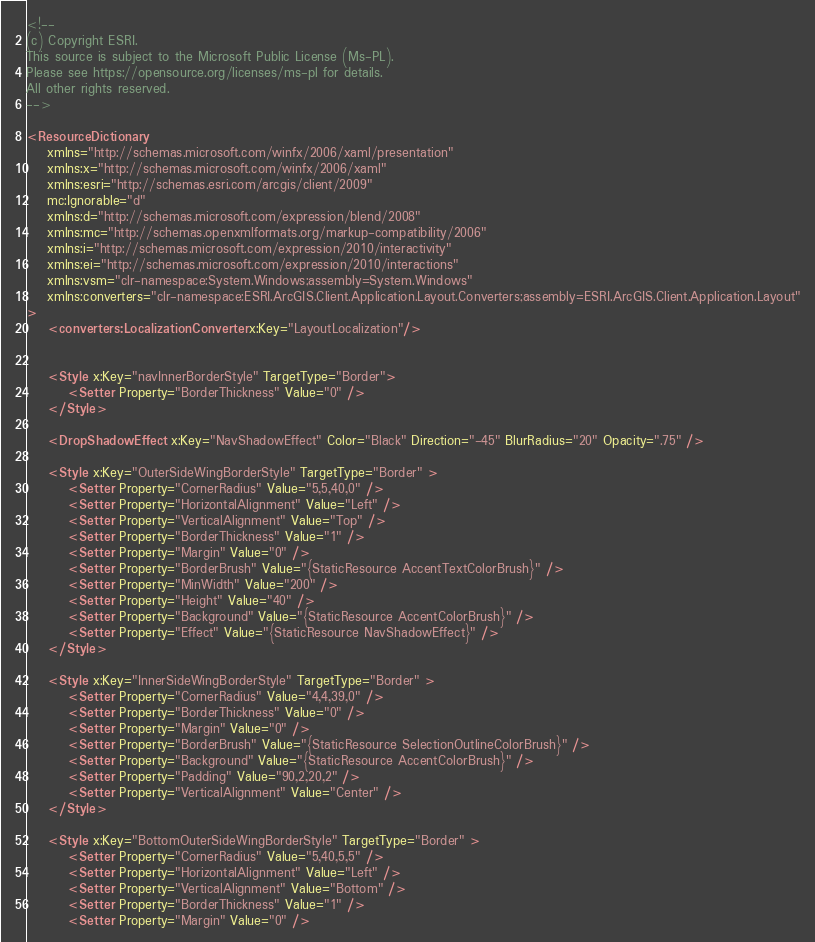<code> <loc_0><loc_0><loc_500><loc_500><_XML_><!--
(c) Copyright ESRI.
This source is subject to the Microsoft Public License (Ms-PL).
Please see https://opensource.org/licenses/ms-pl for details.
All other rights reserved.
-->

<ResourceDictionary
    xmlns="http://schemas.microsoft.com/winfx/2006/xaml/presentation" 
    xmlns:x="http://schemas.microsoft.com/winfx/2006/xaml"    
    xmlns:esri="http://schemas.esri.com/arcgis/client/2009"        
    mc:Ignorable="d" 
    xmlns:d="http://schemas.microsoft.com/expression/blend/2008"
    xmlns:mc="http://schemas.openxmlformats.org/markup-compatibility/2006"
    xmlns:i="http://schemas.microsoft.com/expression/2010/interactivity"
    xmlns:ei="http://schemas.microsoft.com/expression/2010/interactions" 
    xmlns:vsm="clr-namespace:System.Windows;assembly=System.Windows"
	xmlns:converters="clr-namespace:ESRI.ArcGIS.Client.Application.Layout.Converters;assembly=ESRI.ArcGIS.Client.Application.Layout"
>
    <converters:LocalizationConverter x:Key="LayoutLocalization"/>

    
    <Style x:Key="navInnerBorderStyle" TargetType="Border">
        <Setter Property="BorderThickness" Value="0" />
    </Style>

    <DropShadowEffect x:Key="NavShadowEffect" Color="Black" Direction="-45" BlurRadius="20" Opacity=".75" />

    <Style x:Key="OuterSideWingBorderStyle" TargetType="Border" >
        <Setter Property="CornerRadius" Value="5,5,40,0" />
        <Setter Property="HorizontalAlignment" Value="Left" />
        <Setter Property="VerticalAlignment" Value="Top" />
        <Setter Property="BorderThickness" Value="1" />
        <Setter Property="Margin" Value="0" /> 
        <Setter Property="BorderBrush" Value="{StaticResource AccentTextColorBrush}" />
        <Setter Property="MinWidth" Value="200" />
        <Setter Property="Height" Value="40" /> 
        <Setter Property="Background" Value="{StaticResource AccentColorBrush}" />
        <Setter Property="Effect" Value="{StaticResource NavShadowEffect}" />
    </Style>
    
    <Style x:Key="InnerSideWingBorderStyle" TargetType="Border" >
        <Setter Property="CornerRadius" Value="4,4,39,0" />  
        <Setter Property="BorderThickness" Value="0" />
        <Setter Property="Margin" Value="0" />
        <Setter Property="BorderBrush" Value="{StaticResource SelectionOutlineColorBrush}" />
        <Setter Property="Background" Value="{StaticResource AccentColorBrush}" />
        <Setter Property="Padding" Value="90,2,20,2" />
        <Setter Property="VerticalAlignment" Value="Center" />
    </Style>

    <Style x:Key="BottomOuterSideWingBorderStyle" TargetType="Border" >
        <Setter Property="CornerRadius" Value="5,40,5,5" />
        <Setter Property="HorizontalAlignment" Value="Left" />
        <Setter Property="VerticalAlignment" Value="Bottom" />
        <Setter Property="BorderThickness" Value="1" />
        <Setter Property="Margin" Value="0" /></code> 